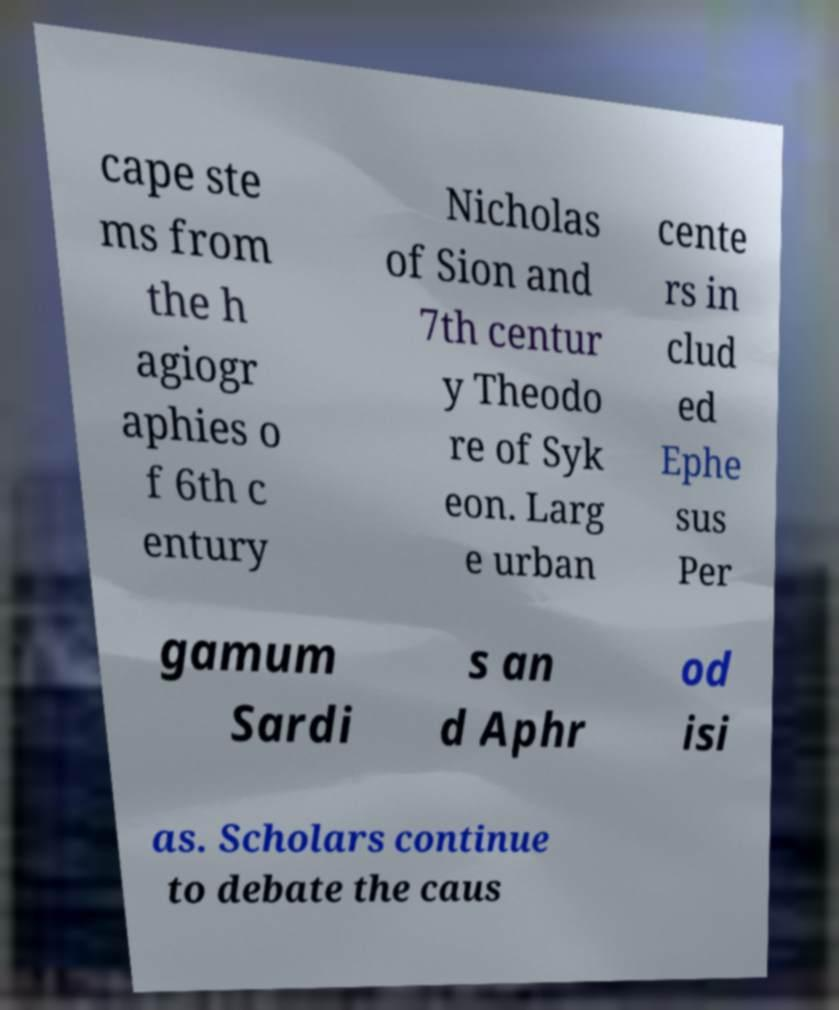Please identify and transcribe the text found in this image. cape ste ms from the h agiogr aphies o f 6th c entury Nicholas of Sion and 7th centur y Theodo re of Syk eon. Larg e urban cente rs in clud ed Ephe sus Per gamum Sardi s an d Aphr od isi as. Scholars continue to debate the caus 